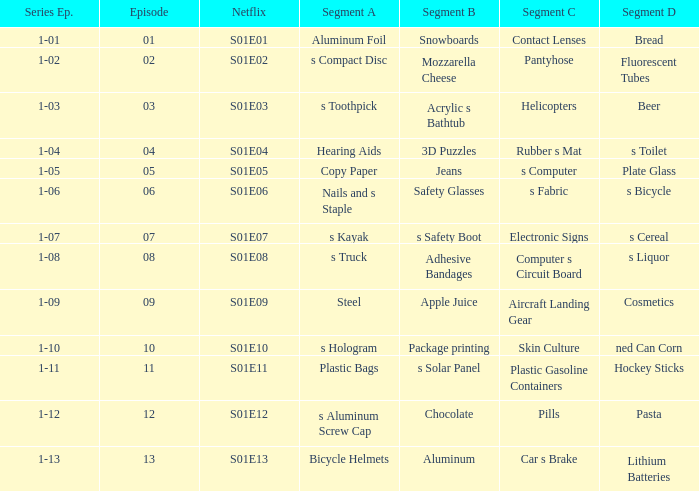What is the netflix digit featuring a section of c of capsules? S01E12. 